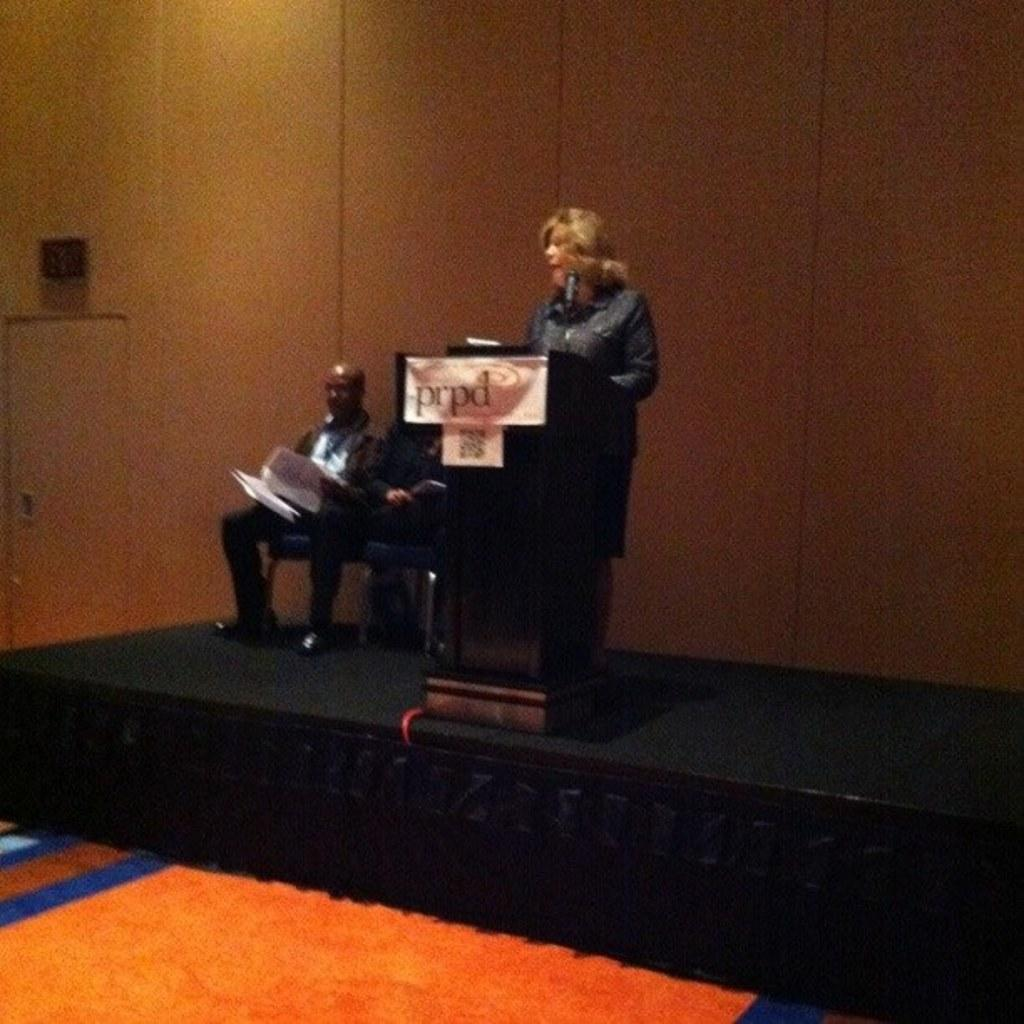How many people are sitting in chairs in the image? There are two men sitting on chairs in the image. What is the woman doing in the image? There is a woman standing in front of a podium on a stage. What can be seen in the background of the image? There is a wooden wall in the background of the image. What is covering the floor in front of the stage? There is a carpet in front of the stage. What type of tent is visible in the image? There is no tent present in the image. 